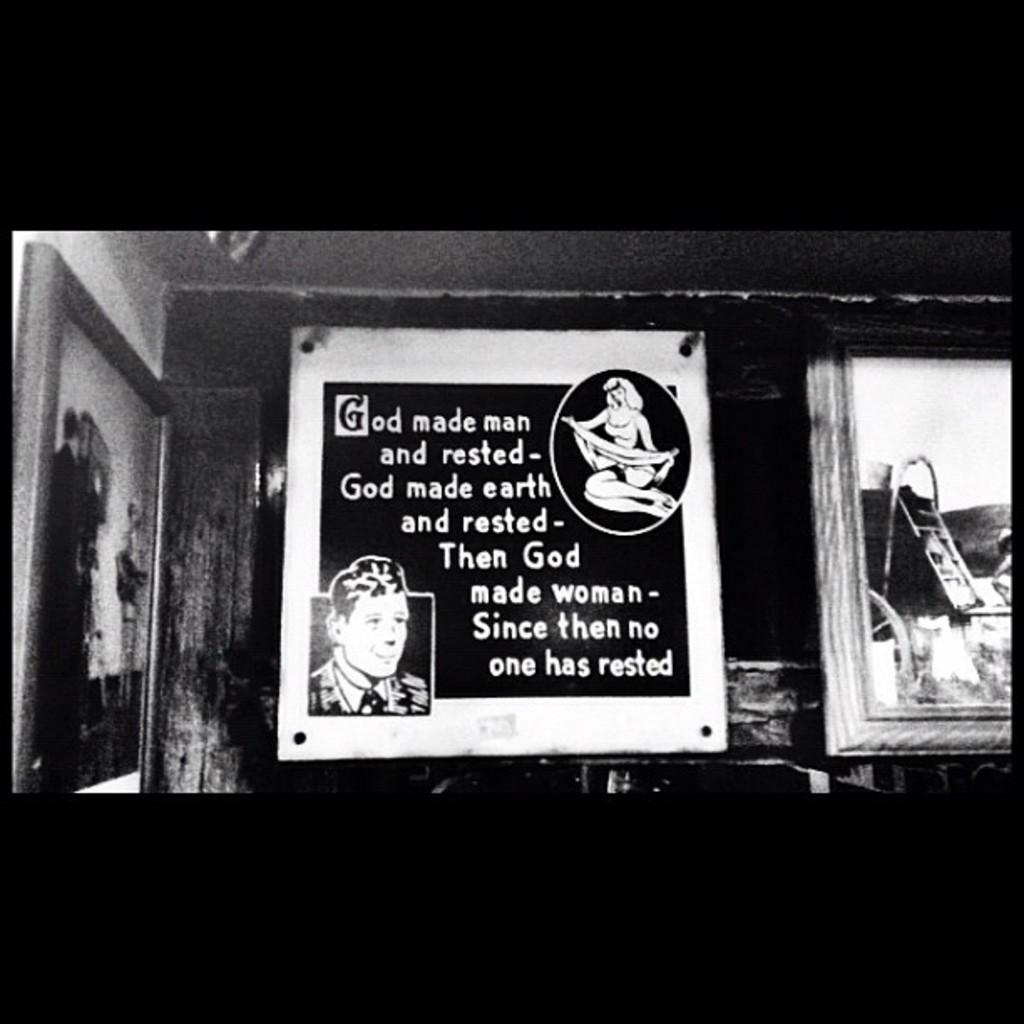Provide a one-sentence caption for the provided image. Poster on a wall that says that "God made man and rested". 